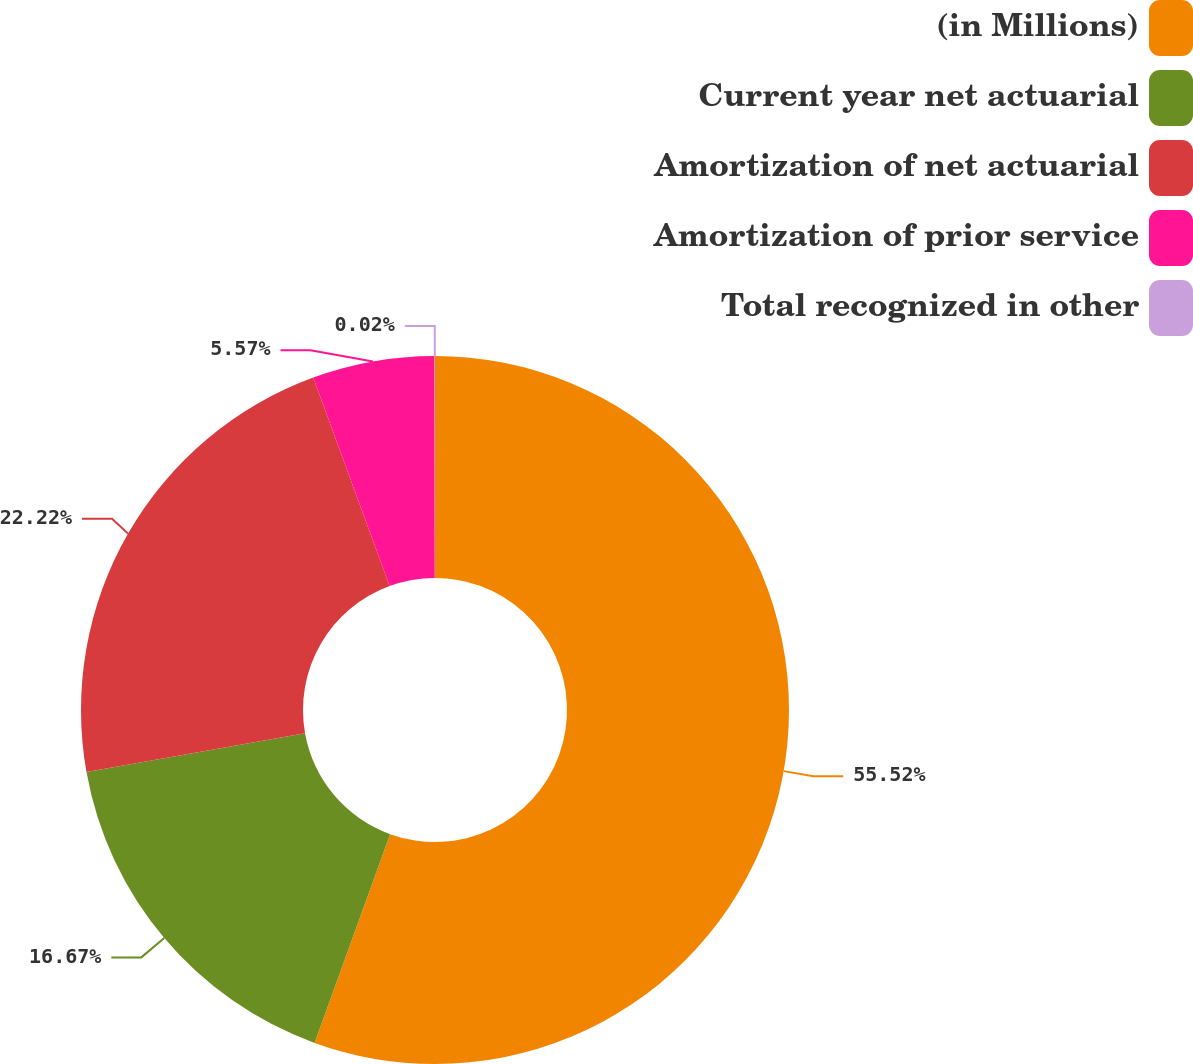<chart> <loc_0><loc_0><loc_500><loc_500><pie_chart><fcel>(in Millions)<fcel>Current year net actuarial<fcel>Amortization of net actuarial<fcel>Amortization of prior service<fcel>Total recognized in other<nl><fcel>55.53%<fcel>16.67%<fcel>22.22%<fcel>5.57%<fcel>0.02%<nl></chart> 